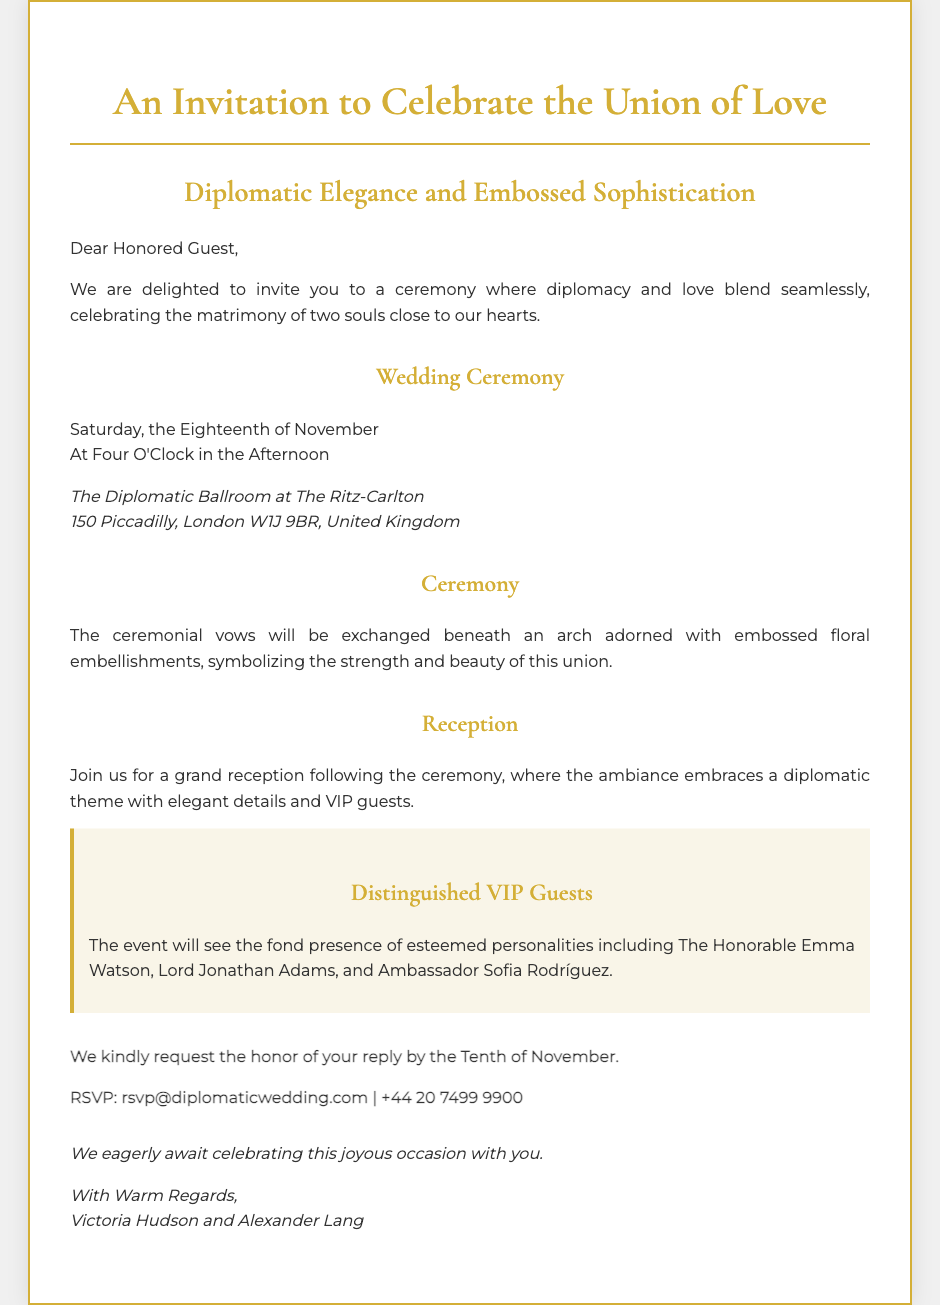What is the date of the wedding ceremony? The date of the wedding ceremony is explicitly stated in the document as Saturday, the Eighteenth of November.
Answer: Eighteenth of November What time does the ceremony start? The time of the ceremony is mentioned as Four O'Clock in the Afternoon.
Answer: Four O'Clock Where is the wedding ceremony being held? The location of the ceremony is given in detail as The Diplomatic Ballroom at The Ritz-Carlton, including the address.
Answer: The Diplomatic Ballroom at The Ritz-Carlton Who are some of the distinguished VIP guests mentioned? The document lists specific names of VIP guests, which allows for a focused answer.
Answer: The Honorable Emma Watson, Lord Jonathan Adams, and Ambassador Sofia Rodríguez What is the RSVP deadline? The RSVP deadline is clearly mentioned in the document, indicating when responses are required.
Answer: Tenth of November What theme does the reception embrace? The theme of the reception is noted in the text, which outlines the overall ambiance expected at the event.
Answer: Diplomatic theme What kind of decorations symbolizing the union are mentioned? The document refers to specific decorations that will be part of the wedding ceremony, indicating their significance.
Answer: Embossed floral embellishments What should attendees do to confirm their attendance? The text specifies the action that guests need to take regarding attendance confirmation, highlighting the means of communication.
Answer: RSVP Who are the hosts of the wedding? The closing section of the document provides the names of the individuals organizing the event.
Answer: Victoria Hudson and Alexander Lang 